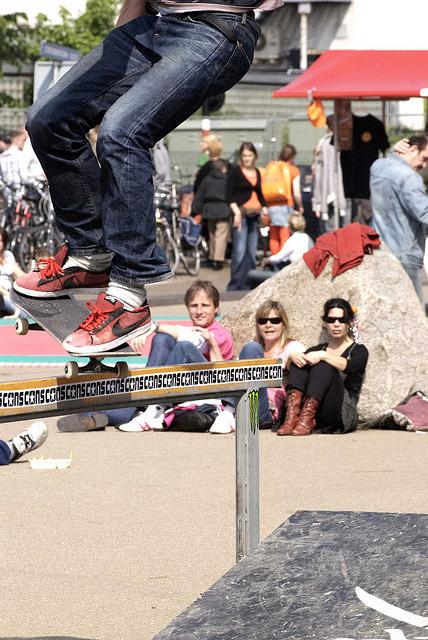What activity is the subject engaged in?
Keep it brief. Skateboarding. What brand of shoes is the skateboarder wearing?
Answer briefly. Nike. Are either of these women wearing sandals?
Keep it brief. No. Are all the skateboards being used?
Keep it brief. Yes. How high up is the skateboarder?
Concise answer only. 3 feet. Is he wearing knee pads?
Concise answer only. No. Do you see graffiti?
Be succinct. No. Does the board have wheels on it?
Short answer required. Yes. 